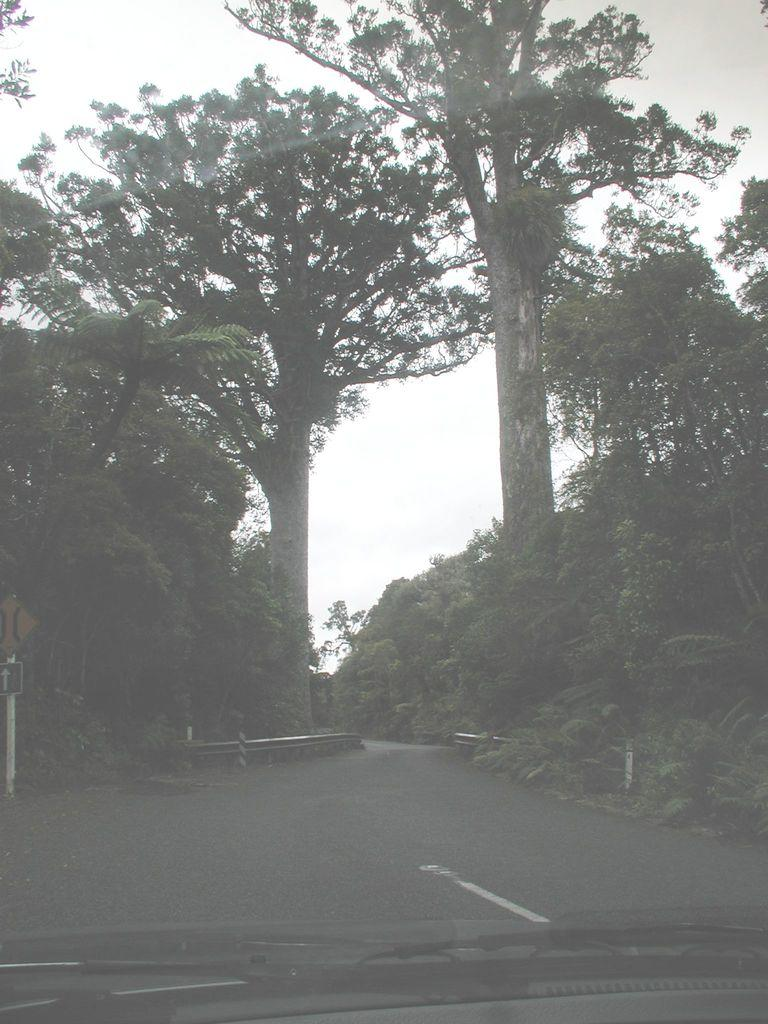What is the main subject of the image? The main subject of the image is a glass of a vehicle. What is located at the bottom of the image? There is a road at the bottom of the image. What can be seen on either side of the road? Trees are present on either side of the road. What is visible at the top of the image? The sky is visible at the top of the image. What type of religion is being practiced by the fairies in the image? There are no fairies present in the image, so it is not possible to determine if any religion is being practiced. Can you hear the sound of thunder in the image? There is no sound present in the image, so it is not possible to hear thunder or any other sound. 